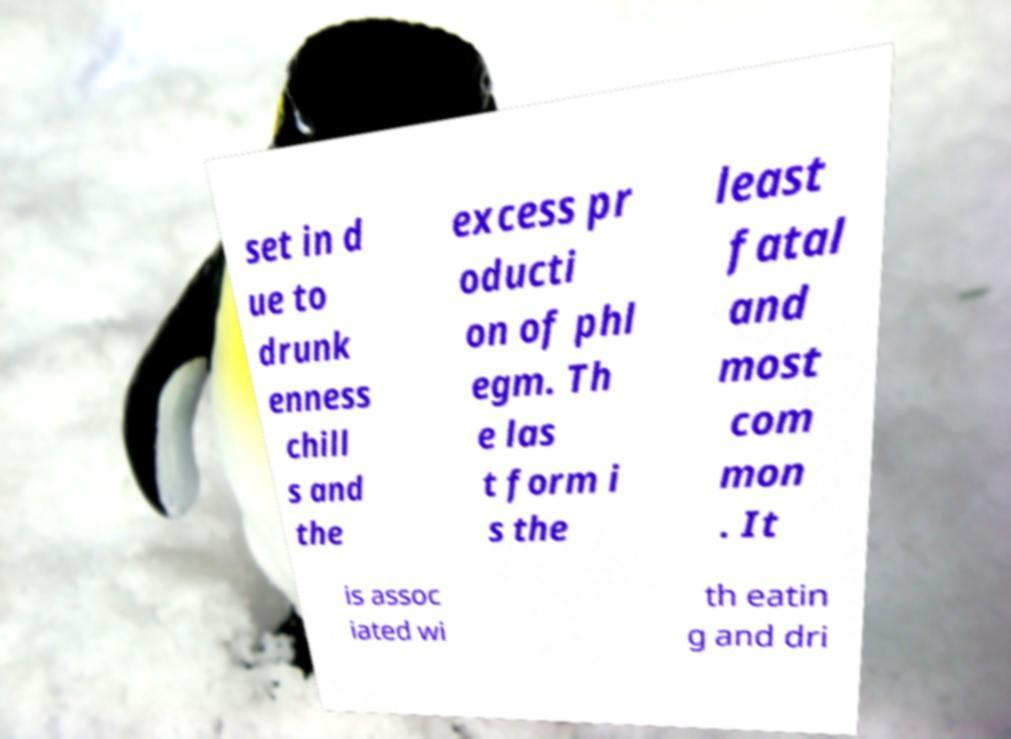Can you accurately transcribe the text from the provided image for me? set in d ue to drunk enness chill s and the excess pr oducti on of phl egm. Th e las t form i s the least fatal and most com mon . It is assoc iated wi th eatin g and dri 